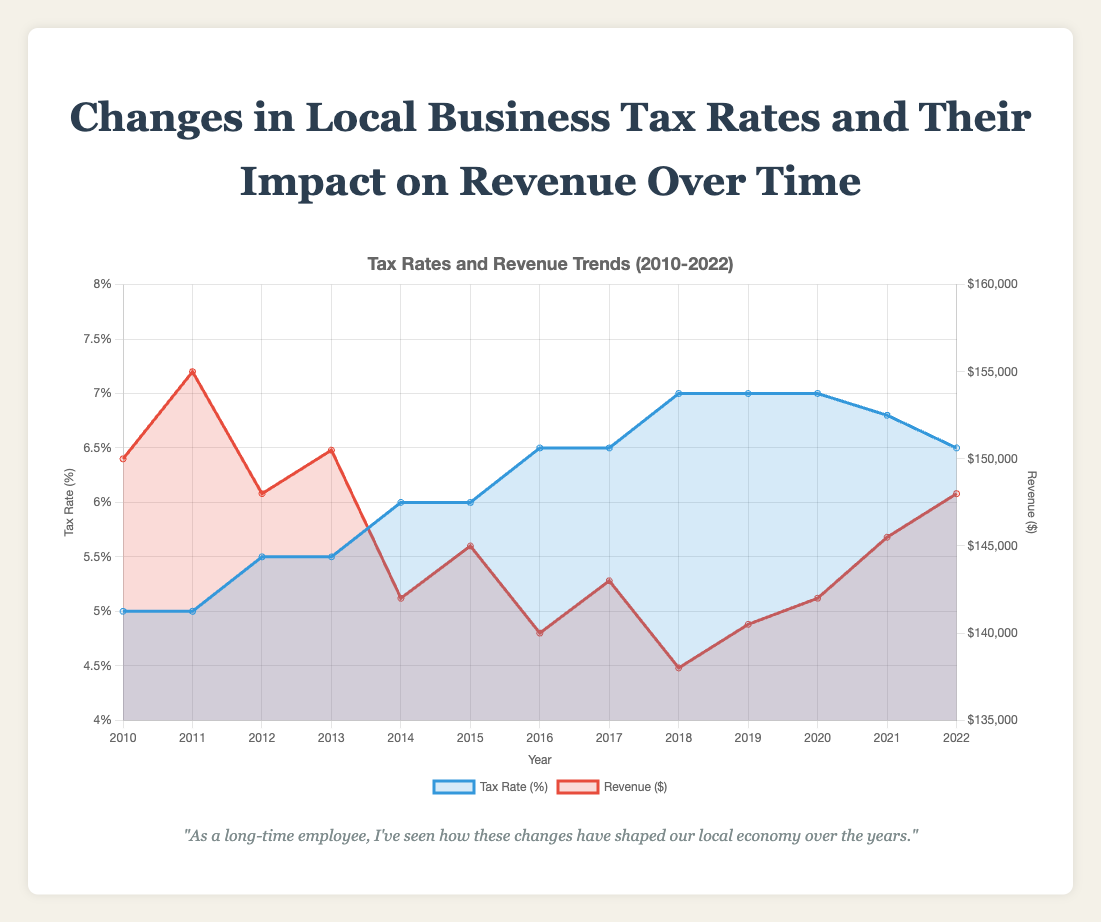What's the title of the figure? The title of the figure is prominently displayed at the top. It reads "Changes in Local Business Tax Rates and Their Impact on Revenue Over Time".
Answer: Changes in Local Business Tax Rates and Their Impact on Revenue Over Time How did the tax rate change from 2010 to 2022? From the figure, observe the Tax Rate curve from 2010 to 2022. The tax rate increased from 5.0% in 2010 to 7.0% by 2018, then decreased to 6.5% by 2022.
Answer: Increased to 7.0%, then decreased to 6.5% In which year was the revenue the highest? By looking at the Revenue curve, the highest point appears to be in 2011 where the revenue is at $155,000.
Answer: 2011 Describe the trend of revenue over the period shown. Between 2010 and 2011, revenue increased. It then fluctuates, showing a general decline until 2018. From 2018 to 2022, there is a slight upward trend.
Answer: Initial increase, general decline, slight rise at end What was the tax rate in the year with the lowest revenue? In 2018, the revenue hit its lowest point at $138,000, while the tax rate was 7.0%.
Answer: 7.0% Compare the revenue in 2014 and 2020. In 2014, the revenue was $142,000 while in 2020, the revenue was $142,000 as well. Despite changes, the revenues in both years were equal.
Answer: Equal During which years did the tax rate remain constant for more than one year? Reviewing the Tax Rate curve, the tax rate was constant from 2010 to 2011 (5.0%), and from 2018 to 2020 (7.0%).
Answer: 2010-2011, 2018-2020 Calculate the average tax rate from 2010 to 2022. Sum all the tax rates from each year and divide by the number of years: (5.0 + 5.0 + 5.5 + 5.5 + 6.0 + 6.0 + 6.5 + 6.5 + 7.0 + 7.0 + 7.0 + 6.8 + 6.5) / 13 = 6.2%.
Answer: 6.2% Explain the correlation between tax rates and revenue based on the figure. Higher tax rates generally correspond to lower revenue. For instance, revenues decline as tax rates increase around 2014-2018. Conversely, revenue seems to rise slightly as tax rates decrease post-2020.
Answer: Higher tax rates correlate with lower revenues 